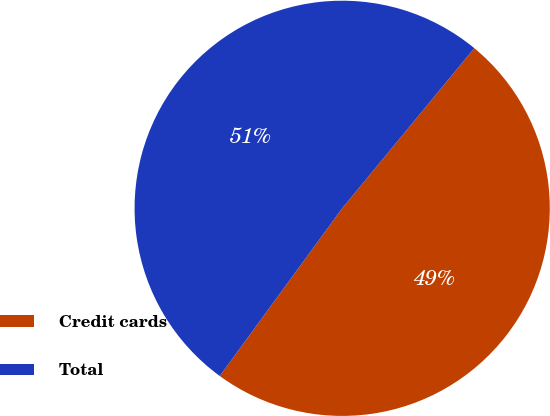Convert chart. <chart><loc_0><loc_0><loc_500><loc_500><pie_chart><fcel>Credit cards<fcel>Total<nl><fcel>49.06%<fcel>50.94%<nl></chart> 